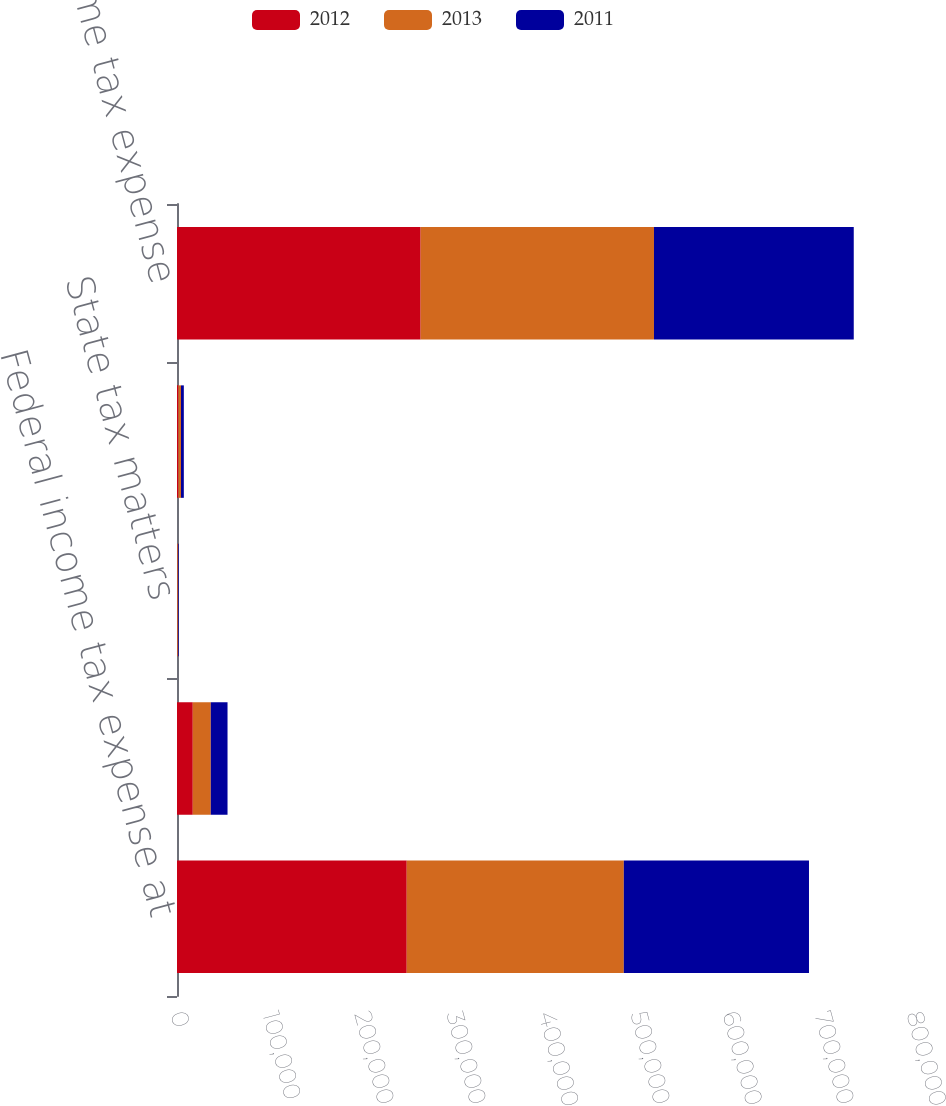Convert chart. <chart><loc_0><loc_0><loc_500><loc_500><stacked_bar_chart><ecel><fcel>Federal income tax expense at<fcel>State income taxes net of<fcel>State tax matters<fcel>Other net<fcel>Total income tax expense<nl><fcel>2012<fcel>249714<fcel>17150<fcel>467<fcel>1565<fcel>264832<nl><fcel>2013<fcel>235954<fcel>19565<fcel>884<fcel>2784<fcel>253619<nl><fcel>2011<fcel>201278<fcel>18210<fcel>737<fcel>3073<fcel>217152<nl></chart> 